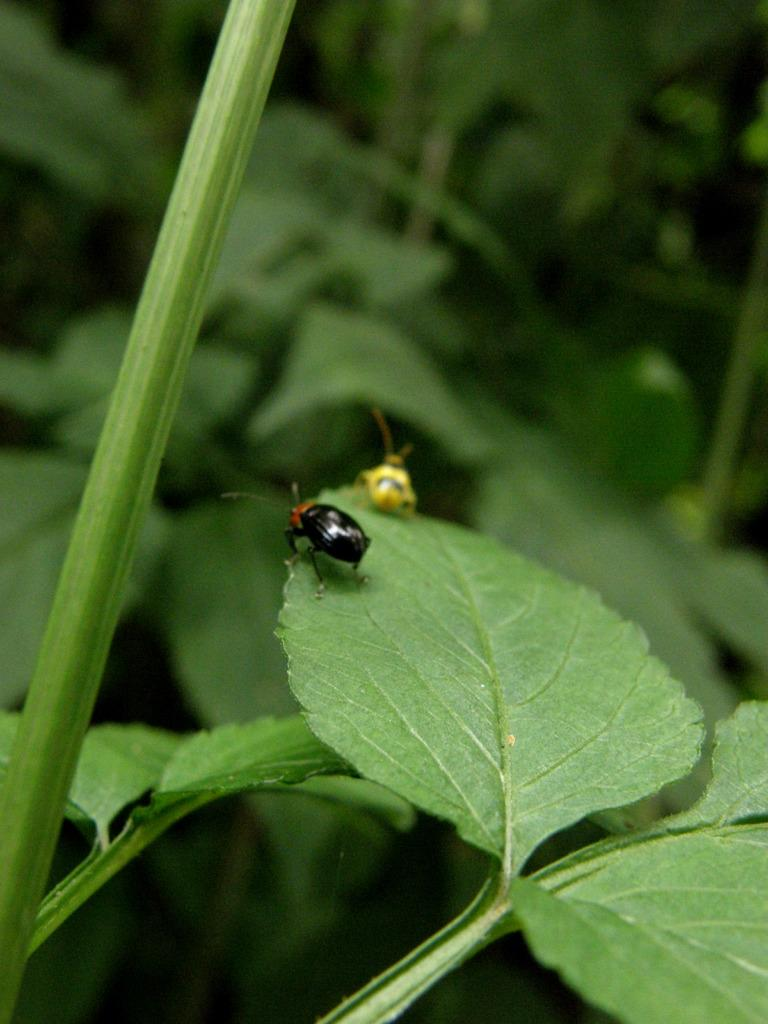What can be seen on the leaf in the image? There are two insects on a leaf in the image. What else is visible in the background of the image? There are stems and leaves visible in the background of the image. What type of digestion system do the insects have in the image? There is no information about the insects' digestion system in the image, as it focuses on their location on the leaf. 